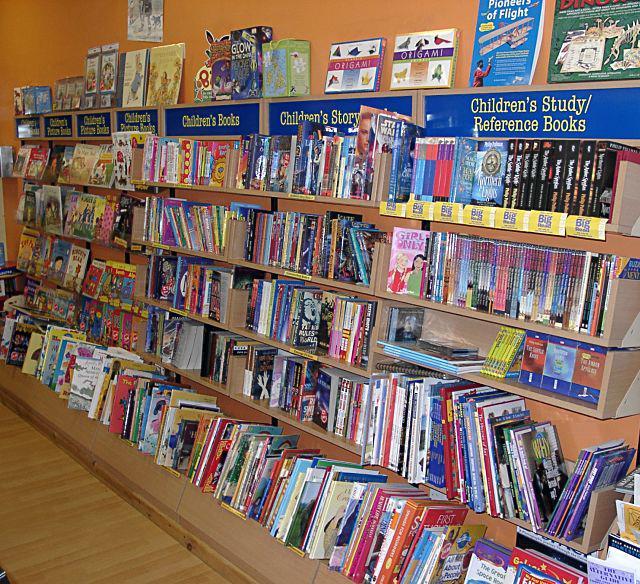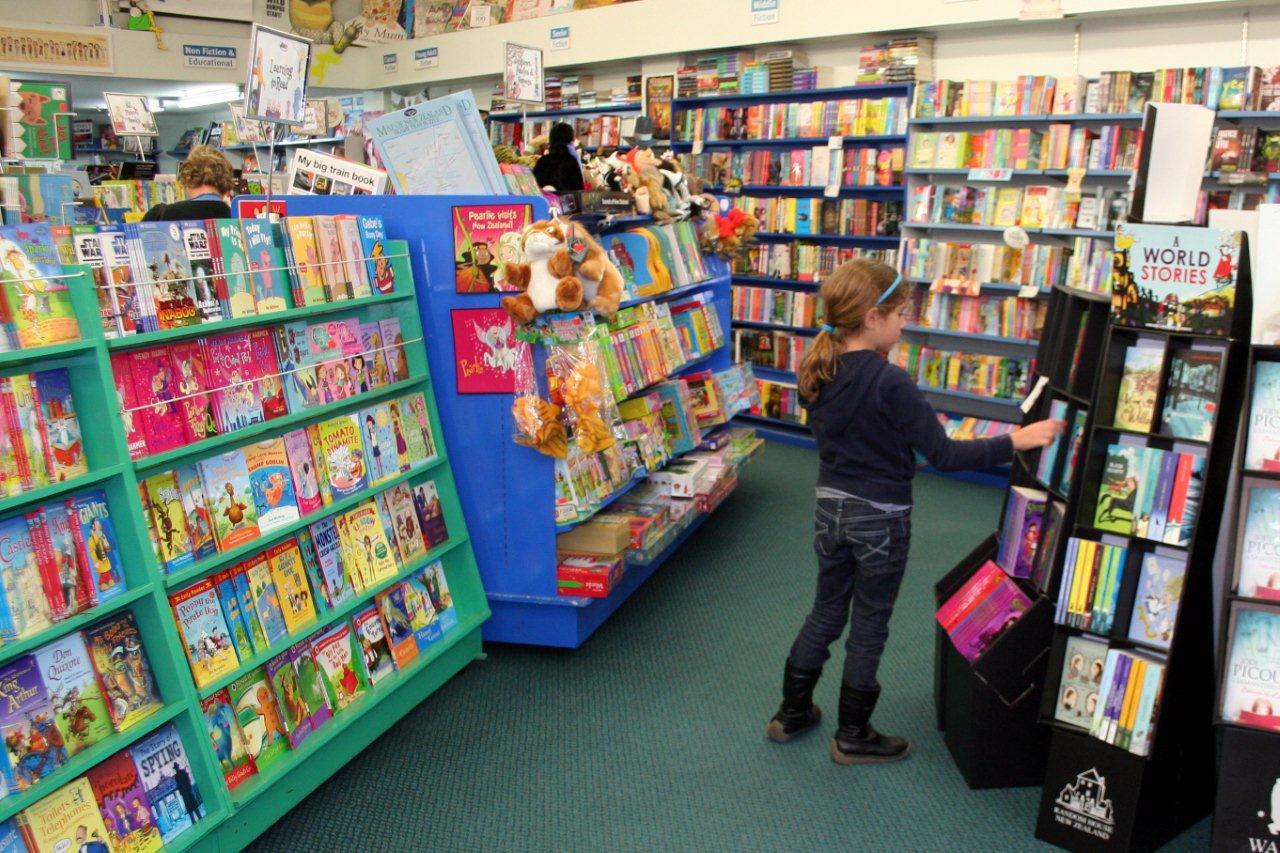The first image is the image on the left, the second image is the image on the right. Analyze the images presented: Is the assertion "There is at least one person in the image on the right." valid? Answer yes or no. Yes. The first image is the image on the left, the second image is the image on the right. For the images shown, is this caption "In one image, the bookshelves themselves are bright yellow." true? Answer yes or no. No. 